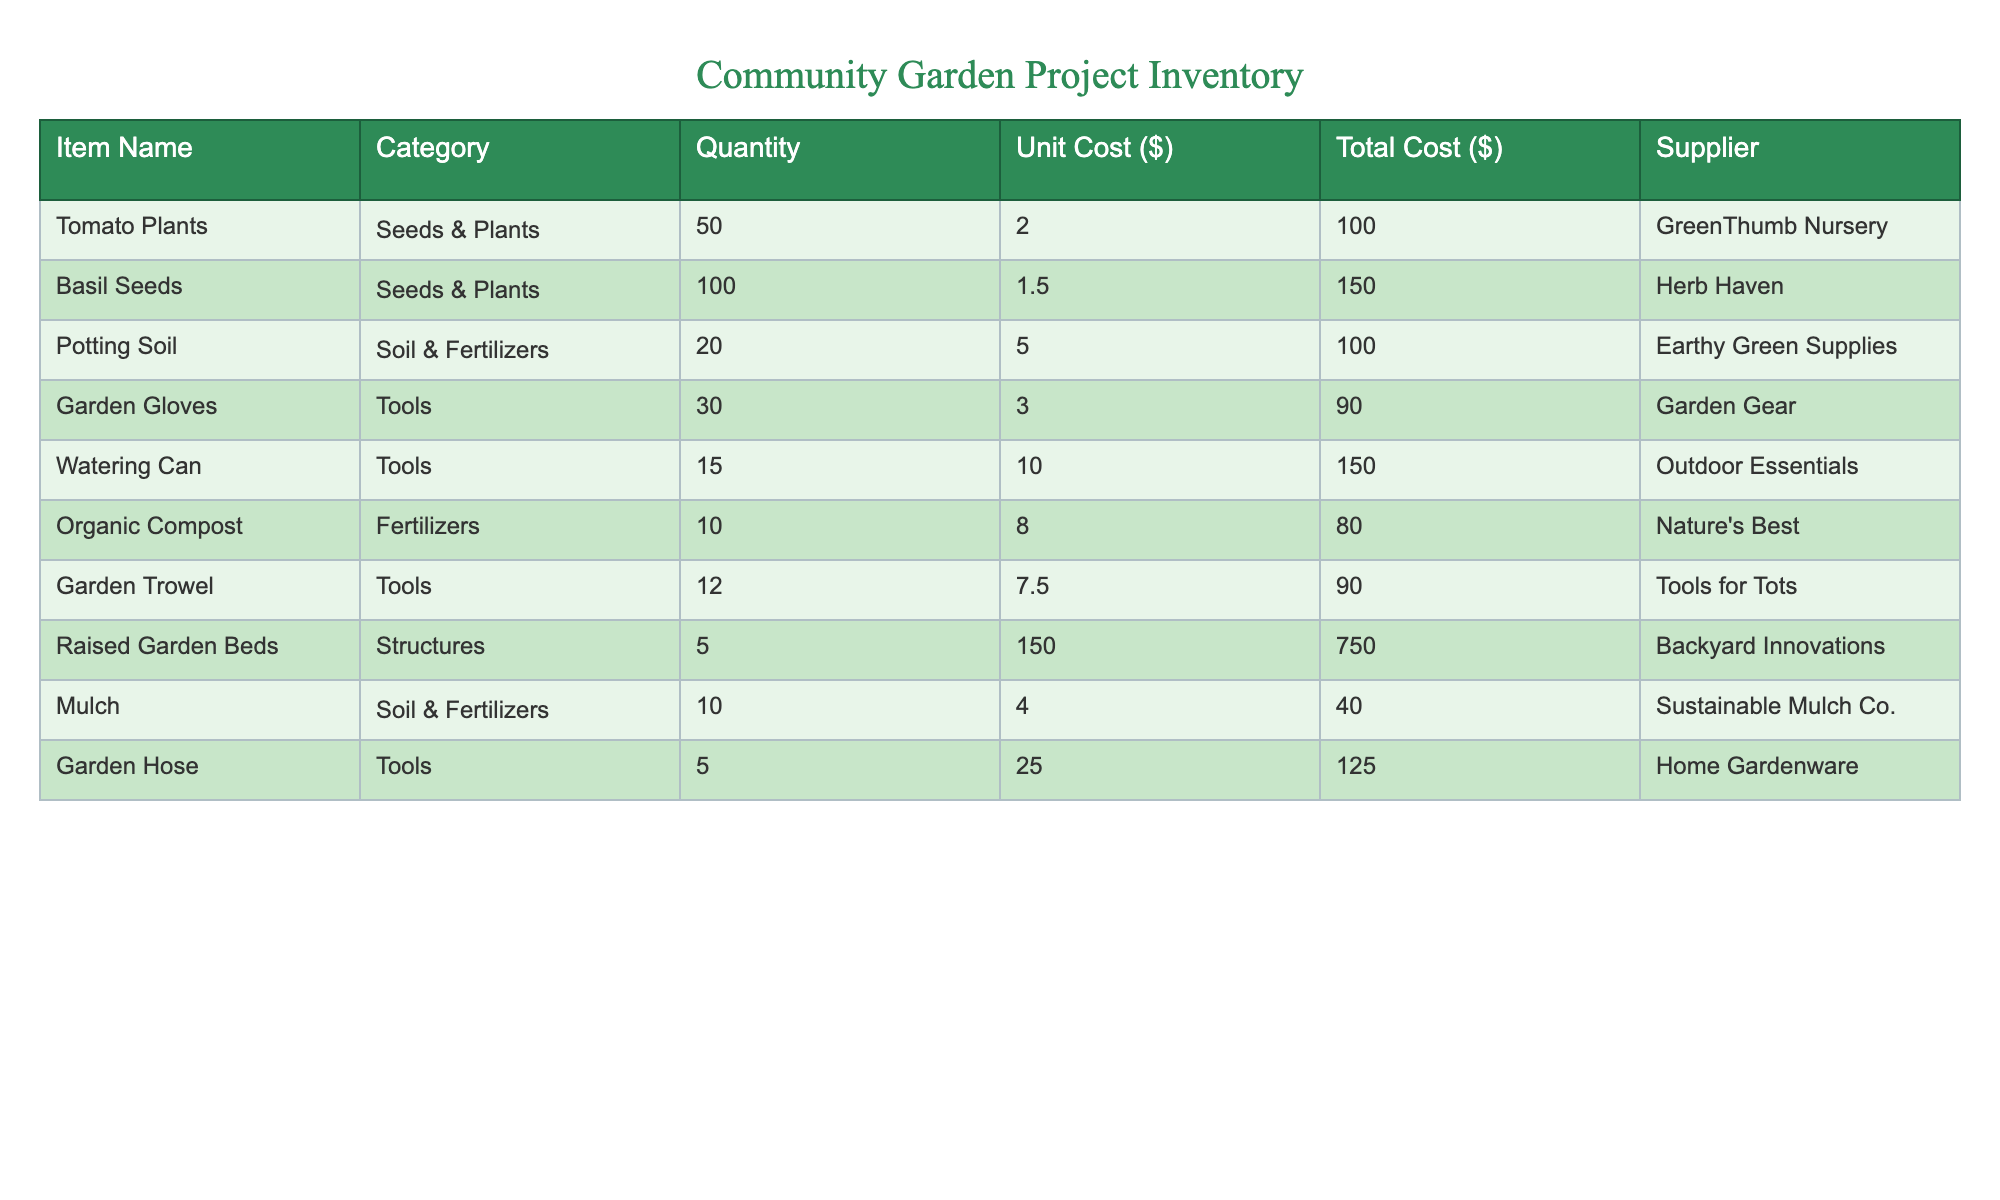What is the total quantity of tomato plants listed in the inventory? The table states that there are 50 tomato plants under the "Seeds & Plants" category. We can directly find this value in the "Quantity" column for the row corresponding to "Tomato Plants."
Answer: 50 Which supplier provides the garden gloves? According to the table, the supplier for garden gloves is "Garden Gear," which can be found in the "Supplier" column next to the "Garden Gloves" item.
Answer: Garden Gear What is the total cost of all the garden structures? The only garden structure listed in the table is "Raised Garden Beds" with a total cost of 750. Since there are no other structures, the total cost remains 750.
Answer: 750 Is the unit cost of organic compost higher than that of potting soil? The unit cost of organic compost is 8.00, while the unit cost of potting soil is 5.00. Since 8.00 is greater than 5.00, the answer is yes.
Answer: Yes What is the average unit cost of the tools listed in the inventory? There are three types of tools: Garden Gloves (3.00), Watering Can (10.00), and Garden Trowel (7.50). Adding these gives 3.00 + 10.00 + 7.50 = 20.50. Dividing by the number of tools (3), the average unit cost is 20.50 / 3 = approximately 6.83.
Answer: 6.83 How many more basil seeds are there compared to organic compost? The quantity of basil seeds is 100, and the quantity of organic compost is 10. To find the difference, we subtract 10 from 100, which gives us 90.
Answer: 90 What is the total quantity of items categorized under "Tools"? The tools listed include Garden Gloves (30), Watering Can (15), Garden Trowel (12), and Garden Hose (5). Adding these quantities gives 30 + 15 + 12 + 5 = 62.
Answer: 62 Is there more mulch or organic compost available in the inventory? The quantity of mulch is 10, and the quantity of organic compost is also 10. As both quantities are equal, the answer is no.
Answer: No What item has the highest total cost? Looking through the total cost column, the "Raised Garden Beds" total cost is 750, which is higher than any other item in the inventory.
Answer: Raised Garden Beds 